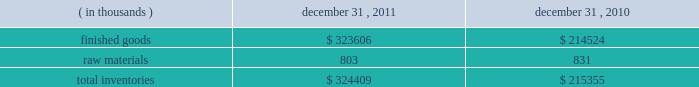Fair value of financial instruments the carrying amounts shown for the company 2019s cash and cash equivalents , accounts receivable and accounts payable approximate fair value because of the short term maturity of those instruments .
The fair value of the long term debt approximates its carrying value based on the variable nature of interest rates and current market rates available to the company .
The fair value of foreign currency forward contracts is based on the net difference between the u.s .
Dollars to be received or paid at the contracts 2019 settlement date and the u.s .
Dollar value of the foreign currency to be sold or purchased at the current forward exchange rate .
Recently issued accounting standards in june 2011 , the financial accounting standards board ( 201cfasb 201d ) issued an accounting standards update which eliminates the option to report other comprehensive income and its components in the statement of changes in stockholders 2019 equity .
It requires an entity to present total comprehensive income , which includes the components of net income and the components of other comprehensive income , either in a single continuous statement or in two separate but consecutive statements .
In december 2011 , the fasb issued an amendment to this pronouncement which defers the specific requirement to present components of reclassifications of other comprehensive income on the face of the income statement .
These pronouncements are effective for financial statements issued for fiscal years , and interim periods within those years , beginning after december 15 , 2011 .
The company believes the adoption of these pronouncements will not have a material impact on its consolidated financial statements .
In may 2011 , the fasb issued an accounting standards update which clarifies requirements for how to measure fair value and for disclosing information about fair value measurements common to accounting principles generally accepted in the united states of america and international financial reporting standards .
This guidance is effective for interim and annual periods beginning on or after december 15 , 2011 .
The company believes the adoption of this guidance will not have a material impact on its consolidated financial statements .
Inventories inventories consisted of the following: .
Acquisitions in july 2011 , the company acquired approximately 400.0 thousand square feet of office space comprising its corporate headquarters for $ 60.5 million .
The acquisition included land , buildings , tenant improvements and third party lease-related intangible assets .
As of the purchase date , 163.6 thousand square feet of the 400.0 thousand square feet acquired was leased to third party tenants .
These leases had remaining lease terms ranging from 9 months to 15 years on the purchase date .
The company intends to occupy additional space as it becomes available .
Since the acquisition , the company has invested $ 2.2 million in additional improvements .
The acquisition included the assumption of a $ 38.6 million loan secured by the property and the remaining purchase price was paid in cash funded primarily by a $ 25.0 million term loan borrowed in may 2011 .
The carrying value of the assumed loan approximated its fair value on the date of the acquisition .
Refer to note 7 for .
As part of the july 2011 acquisition of the property what was the percent of the assumed loan to the purchase price? 
Computations: (38.6 / 60.5)
Answer: 0.63802. 